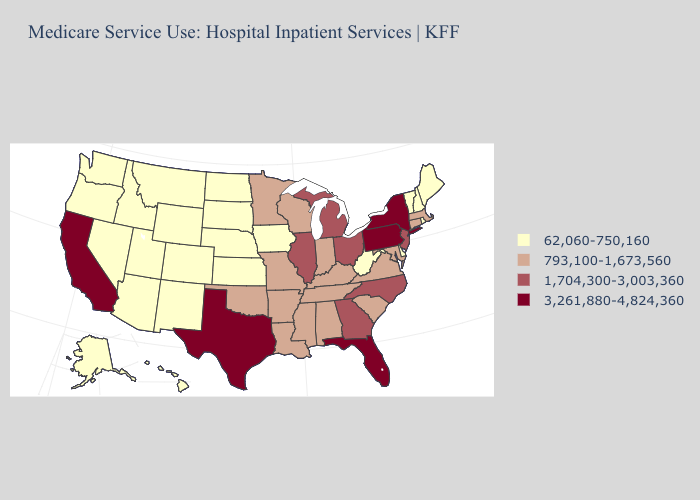Name the states that have a value in the range 3,261,880-4,824,360?
Quick response, please. California, Florida, New York, Pennsylvania, Texas. Does the map have missing data?
Keep it brief. No. Does North Dakota have the lowest value in the MidWest?
Keep it brief. Yes. Is the legend a continuous bar?
Short answer required. No. Name the states that have a value in the range 1,704,300-3,003,360?
Short answer required. Georgia, Illinois, Michigan, New Jersey, North Carolina, Ohio. Does California have the same value as Pennsylvania?
Give a very brief answer. Yes. Which states hav the highest value in the MidWest?
Keep it brief. Illinois, Michigan, Ohio. Does the first symbol in the legend represent the smallest category?
Concise answer only. Yes. Name the states that have a value in the range 62,060-750,160?
Write a very short answer. Alaska, Arizona, Colorado, Delaware, Hawaii, Idaho, Iowa, Kansas, Maine, Montana, Nebraska, Nevada, New Hampshire, New Mexico, North Dakota, Oregon, Rhode Island, South Dakota, Utah, Vermont, Washington, West Virginia, Wyoming. Does West Virginia have the highest value in the USA?
Keep it brief. No. What is the value of Montana?
Answer briefly. 62,060-750,160. Name the states that have a value in the range 3,261,880-4,824,360?
Write a very short answer. California, Florida, New York, Pennsylvania, Texas. Name the states that have a value in the range 3,261,880-4,824,360?
Keep it brief. California, Florida, New York, Pennsylvania, Texas. 